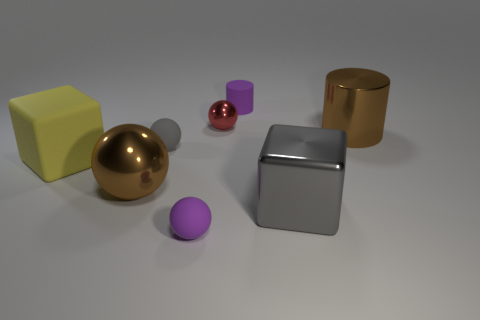What is the color of the metal ball that is left of the metallic ball behind the small gray thing?
Offer a terse response. Brown. There is a brown object that is behind the yellow rubber thing; does it have the same shape as the purple matte thing that is behind the shiny cube?
Your answer should be compact. Yes. What shape is the metal thing that is the same size as the matte cylinder?
Provide a short and direct response. Sphere. The small sphere that is made of the same material as the tiny gray object is what color?
Your response must be concise. Purple. There is a tiny metallic thing; is its shape the same as the small object that is in front of the tiny gray sphere?
Provide a short and direct response. Yes. There is a thing that is the same color as the matte cylinder; what is its material?
Provide a short and direct response. Rubber. There is a brown object that is the same size as the brown sphere; what is its material?
Provide a short and direct response. Metal. Are there any matte spheres that have the same color as the rubber cylinder?
Make the answer very short. Yes. What is the shape of the large metallic thing that is both behind the large gray object and in front of the gray rubber ball?
Ensure brevity in your answer.  Sphere. What number of purple balls have the same material as the purple cylinder?
Your answer should be very brief. 1. 